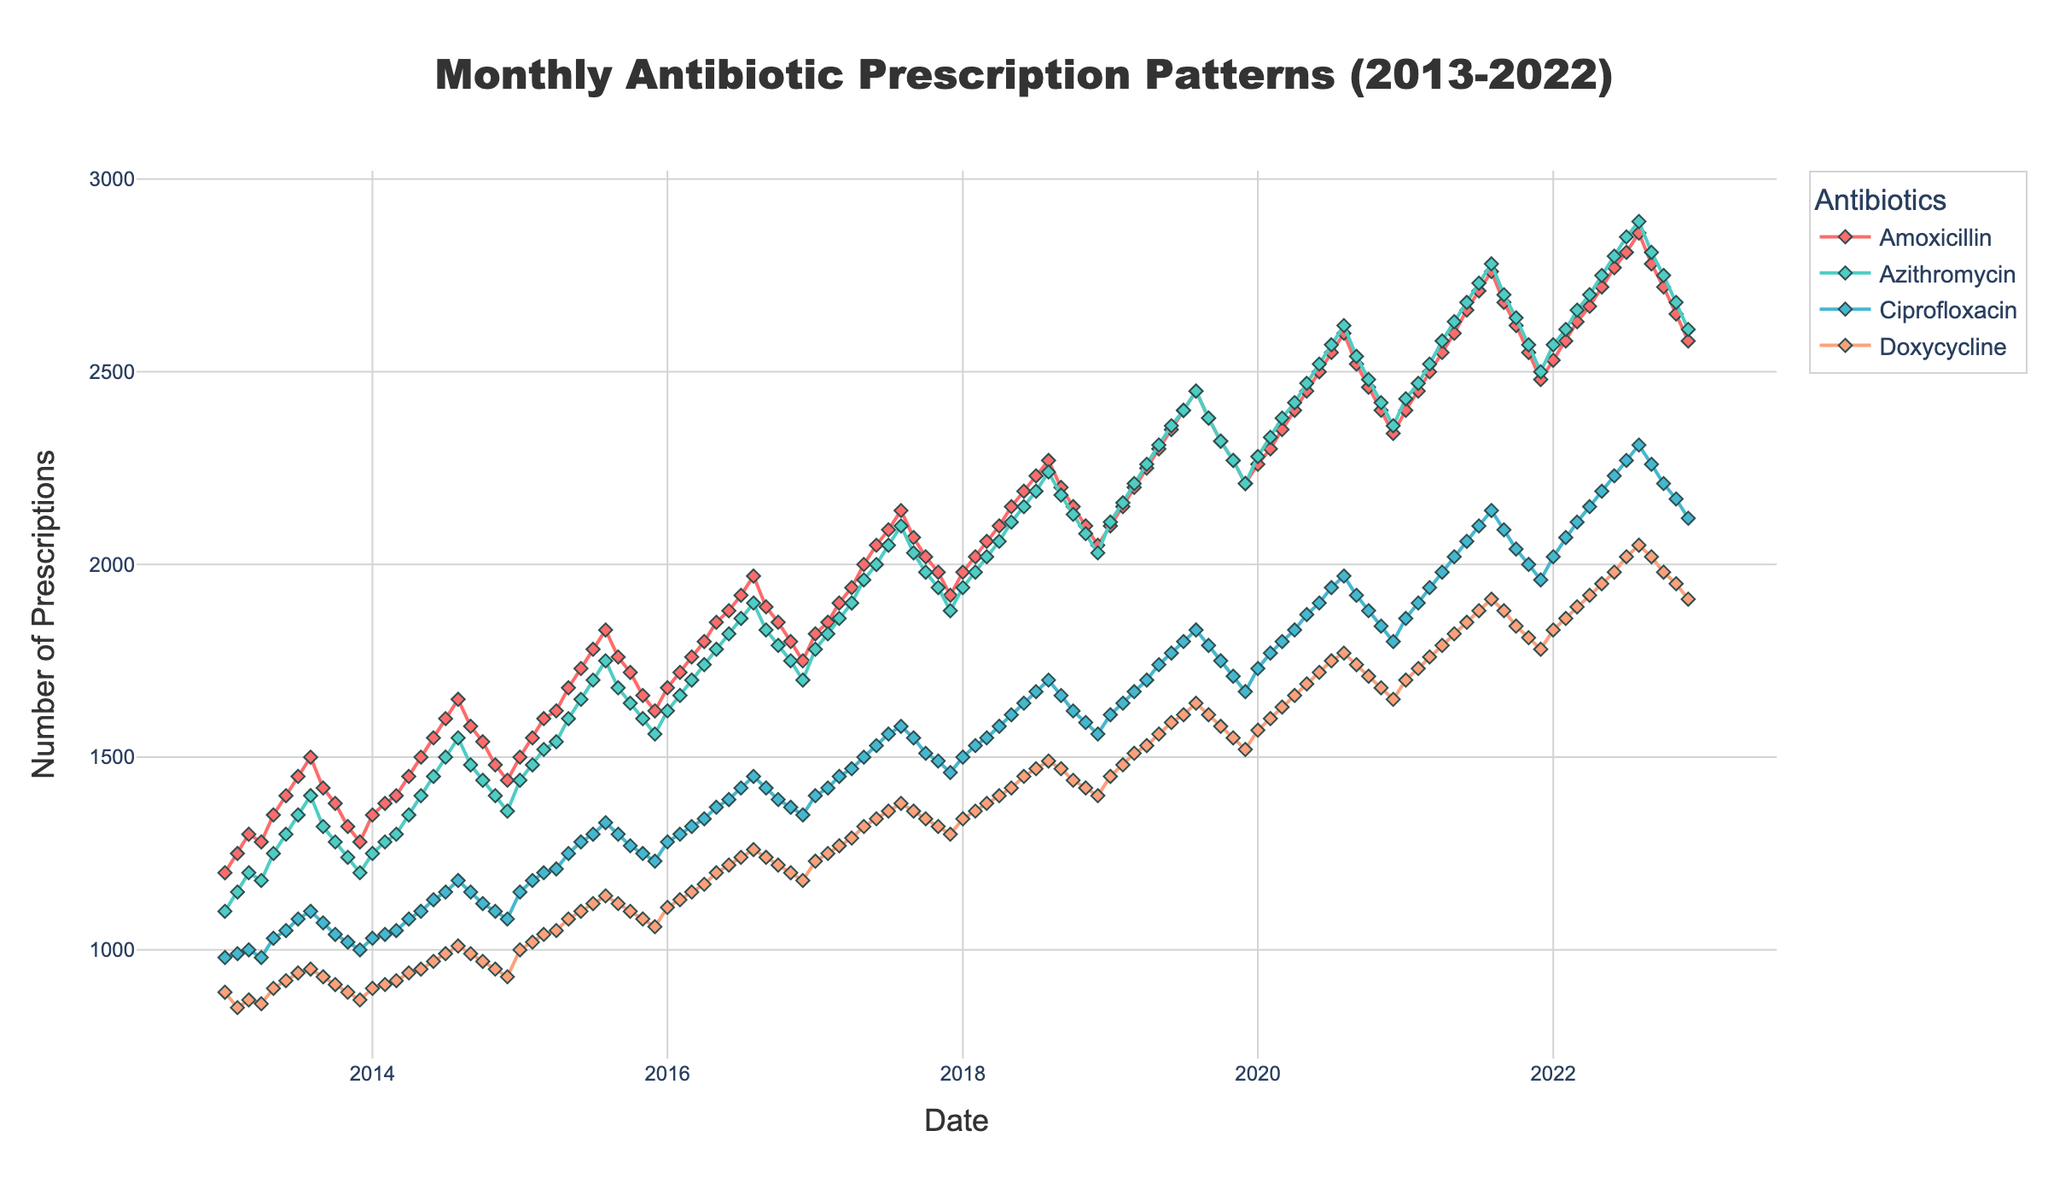What is the title of the figure? The title of the figure is displayed at the top and centered above the plot. It summarizes the main content portrayed by the figure, indicating a focus on monthly patterns in antibiotic prescriptions.
Answer: Monthly Antibiotic Prescription Patterns (2013-2022) What are the labels for the axes? The labels for the axes provide information about what each axis represents. The x-axis label is positioned below the horizontal axis, and the y-axis label is adjacent to the vertical axis.
Answer: The x-axis is labeled "Date" and the y-axis is labeled "Number of Prescriptions." How many antibiotics are represented in the figure? The figure uses different colors and markers to represent each antibiotic. Counting these unique color-coded markers in the legend identifies the number of antibiotics.
Answer: 4 Which antibiotic had the highest number of prescriptions in July 2021? Locate July 2021 on the x-axis and find the point on the plot corresponding to each antibiotic for that month. The antibiotic with the highest y-value (number of prescriptions) has the highest count.
Answer: Amoxicillin By how much did the number of Amoxicillin prescriptions change from January 2013 to December 2022? Find the y-values representing Amoxicillin prescriptions in January 2013 and December 2022. Subtract the January 2013 value from the December 2022 value to find the change.
Answer: 1380 (2580 - 1200) Which antibiotic shows the most significant seasonal (monthly) variation throughout the years? Observe the fluctuations of each antibiotic's line over the years. The antibiotic with the most pronounced peaks and troughs across the months depicts the most significant variation.
Answer: Amoxicillin In which month and year was the highest total number of antibiotic prescriptions recorded (summing all four antibiotics)? Sum the prescriptions for all four antibiotics for each month and compare to identify the highest total. The date corresponding to this highest value is the answer.
Answer: August 2022 Between 2013 and 2022, during which year did Azithromycin prescriptions demonstrate the smallest increase from January to December? For each year, determine the difference in Azithromycin prescriptions between January and December. Identify the year with the smallest difference.
Answer: 2013 Compare the number of Ciprofloxacin and Doxycycline prescriptions in November 2019. Which was higher and by how much? Locate November 2019 on the x-axis and identify the y-values for Ciprofloxacin and Doxycycline. Subtract the smaller value from the larger one to determine the difference.
Answer: Ciprofloxacin was higher by 160. (1710 - 1550) What trend can be observed in the prescriptions of Doxycycline from January 2020 to December 2021? Trace the line representing Doxycycline from January 2020 to December 2021 and describe the general direction (upward, downward, or stable).
Answer: Upward trend 